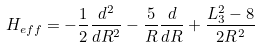<formula> <loc_0><loc_0><loc_500><loc_500>H _ { e f f } = - \frac { 1 } { 2 } \frac { d ^ { 2 } } { d R ^ { 2 } } - \frac { 5 } { R } \frac { d } { d R } + \frac { L _ { 3 } ^ { 2 } - 8 } { 2 R ^ { 2 } }</formula> 